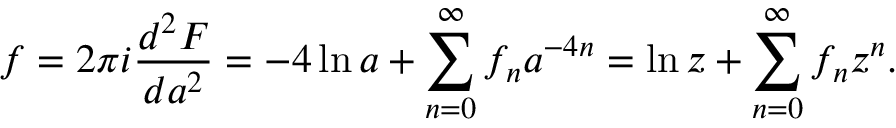Convert formula to latex. <formula><loc_0><loc_0><loc_500><loc_500>f = 2 \pi i \frac { d ^ { 2 } F } { d a ^ { 2 } } = - 4 \ln a + \sum _ { n = 0 } ^ { \infty } f _ { n } a ^ { - 4 n } = \ln z + \sum _ { n = 0 } ^ { \infty } f _ { n } z ^ { n } .</formula> 